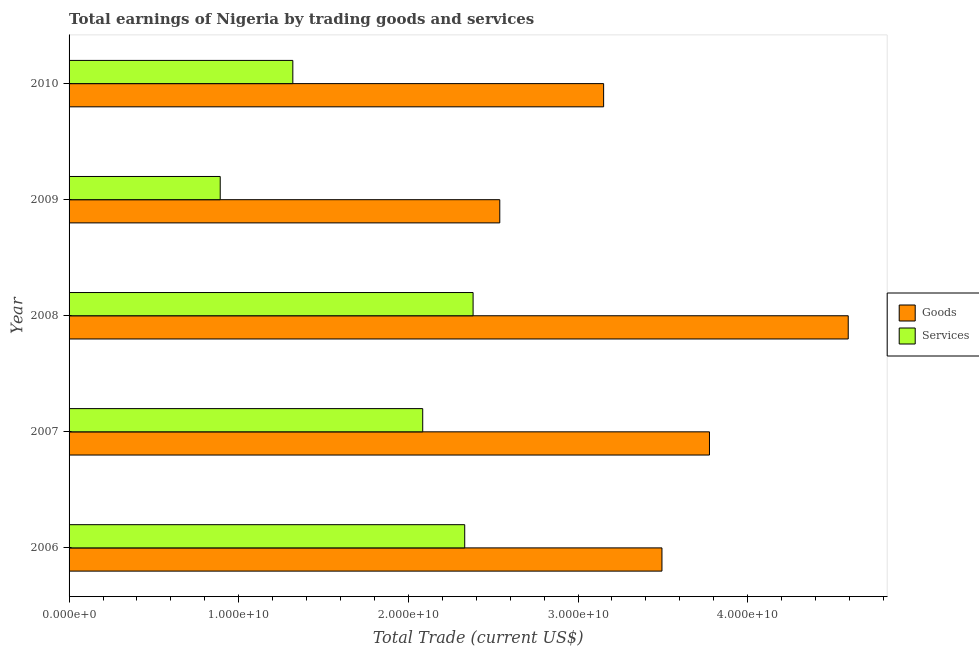How many different coloured bars are there?
Your response must be concise. 2. Are the number of bars per tick equal to the number of legend labels?
Your response must be concise. Yes. Are the number of bars on each tick of the Y-axis equal?
Your answer should be compact. Yes. How many bars are there on the 1st tick from the top?
Make the answer very short. 2. How many bars are there on the 3rd tick from the bottom?
Give a very brief answer. 2. What is the label of the 3rd group of bars from the top?
Keep it short and to the point. 2008. What is the amount earned by trading goods in 2010?
Your answer should be compact. 3.15e+1. Across all years, what is the maximum amount earned by trading services?
Ensure brevity in your answer.  2.38e+1. Across all years, what is the minimum amount earned by trading services?
Your answer should be compact. 8.91e+09. What is the total amount earned by trading services in the graph?
Your answer should be very brief. 9.01e+1. What is the difference between the amount earned by trading services in 2007 and that in 2009?
Provide a short and direct response. 1.19e+1. What is the difference between the amount earned by trading goods in 2009 and the amount earned by trading services in 2006?
Your response must be concise. 2.07e+09. What is the average amount earned by trading services per year?
Ensure brevity in your answer.  1.80e+1. In the year 2008, what is the difference between the amount earned by trading services and amount earned by trading goods?
Your response must be concise. -2.21e+1. What is the ratio of the amount earned by trading goods in 2007 to that in 2010?
Offer a very short reply. 1.2. Is the difference between the amount earned by trading goods in 2008 and 2010 greater than the difference between the amount earned by trading services in 2008 and 2010?
Ensure brevity in your answer.  Yes. What is the difference between the highest and the second highest amount earned by trading goods?
Provide a short and direct response. 8.18e+09. What is the difference between the highest and the lowest amount earned by trading goods?
Your response must be concise. 2.05e+1. In how many years, is the amount earned by trading goods greater than the average amount earned by trading goods taken over all years?
Your answer should be very brief. 2. What does the 2nd bar from the top in 2010 represents?
Your response must be concise. Goods. What does the 2nd bar from the bottom in 2007 represents?
Your answer should be compact. Services. How many bars are there?
Your answer should be compact. 10. How many years are there in the graph?
Provide a short and direct response. 5. Does the graph contain any zero values?
Give a very brief answer. No. Where does the legend appear in the graph?
Offer a terse response. Center right. How many legend labels are there?
Offer a terse response. 2. How are the legend labels stacked?
Offer a terse response. Vertical. What is the title of the graph?
Ensure brevity in your answer.  Total earnings of Nigeria by trading goods and services. Does "Old" appear as one of the legend labels in the graph?
Provide a short and direct response. No. What is the label or title of the X-axis?
Your answer should be compact. Total Trade (current US$). What is the Total Trade (current US$) of Goods in 2006?
Offer a very short reply. 3.49e+1. What is the Total Trade (current US$) in Services in 2006?
Offer a very short reply. 2.33e+1. What is the Total Trade (current US$) of Goods in 2007?
Ensure brevity in your answer.  3.77e+1. What is the Total Trade (current US$) of Services in 2007?
Make the answer very short. 2.08e+1. What is the Total Trade (current US$) of Goods in 2008?
Provide a short and direct response. 4.59e+1. What is the Total Trade (current US$) of Services in 2008?
Keep it short and to the point. 2.38e+1. What is the Total Trade (current US$) of Goods in 2009?
Keep it short and to the point. 2.54e+1. What is the Total Trade (current US$) in Services in 2009?
Your answer should be very brief. 8.91e+09. What is the Total Trade (current US$) in Goods in 2010?
Ensure brevity in your answer.  3.15e+1. What is the Total Trade (current US$) in Services in 2010?
Keep it short and to the point. 1.32e+1. Across all years, what is the maximum Total Trade (current US$) of Goods?
Ensure brevity in your answer.  4.59e+1. Across all years, what is the maximum Total Trade (current US$) in Services?
Provide a succinct answer. 2.38e+1. Across all years, what is the minimum Total Trade (current US$) of Goods?
Offer a very short reply. 2.54e+1. Across all years, what is the minimum Total Trade (current US$) of Services?
Give a very brief answer. 8.91e+09. What is the total Total Trade (current US$) of Goods in the graph?
Your answer should be very brief. 1.76e+11. What is the total Total Trade (current US$) in Services in the graph?
Keep it short and to the point. 9.01e+1. What is the difference between the Total Trade (current US$) of Goods in 2006 and that in 2007?
Make the answer very short. -2.80e+09. What is the difference between the Total Trade (current US$) of Services in 2006 and that in 2007?
Offer a very short reply. 2.48e+09. What is the difference between the Total Trade (current US$) of Goods in 2006 and that in 2008?
Offer a terse response. -1.10e+1. What is the difference between the Total Trade (current US$) in Services in 2006 and that in 2008?
Your answer should be compact. -4.93e+08. What is the difference between the Total Trade (current US$) in Goods in 2006 and that in 2009?
Keep it short and to the point. 9.56e+09. What is the difference between the Total Trade (current US$) in Services in 2006 and that in 2009?
Offer a terse response. 1.44e+1. What is the difference between the Total Trade (current US$) of Goods in 2006 and that in 2010?
Ensure brevity in your answer.  3.44e+09. What is the difference between the Total Trade (current US$) of Services in 2006 and that in 2010?
Provide a short and direct response. 1.01e+1. What is the difference between the Total Trade (current US$) in Goods in 2007 and that in 2008?
Your answer should be very brief. -8.18e+09. What is the difference between the Total Trade (current US$) of Services in 2007 and that in 2008?
Ensure brevity in your answer.  -2.97e+09. What is the difference between the Total Trade (current US$) in Goods in 2007 and that in 2009?
Provide a succinct answer. 1.24e+1. What is the difference between the Total Trade (current US$) in Services in 2007 and that in 2009?
Ensure brevity in your answer.  1.19e+1. What is the difference between the Total Trade (current US$) in Goods in 2007 and that in 2010?
Offer a terse response. 6.24e+09. What is the difference between the Total Trade (current US$) of Services in 2007 and that in 2010?
Provide a short and direct response. 7.66e+09. What is the difference between the Total Trade (current US$) of Goods in 2008 and that in 2009?
Keep it short and to the point. 2.05e+1. What is the difference between the Total Trade (current US$) in Services in 2008 and that in 2009?
Make the answer very short. 1.49e+1. What is the difference between the Total Trade (current US$) of Goods in 2008 and that in 2010?
Provide a succinct answer. 1.44e+1. What is the difference between the Total Trade (current US$) in Services in 2008 and that in 2010?
Provide a succinct answer. 1.06e+1. What is the difference between the Total Trade (current US$) of Goods in 2009 and that in 2010?
Keep it short and to the point. -6.12e+09. What is the difference between the Total Trade (current US$) in Services in 2009 and that in 2010?
Provide a short and direct response. -4.28e+09. What is the difference between the Total Trade (current US$) of Goods in 2006 and the Total Trade (current US$) of Services in 2007?
Offer a very short reply. 1.41e+1. What is the difference between the Total Trade (current US$) of Goods in 2006 and the Total Trade (current US$) of Services in 2008?
Keep it short and to the point. 1.11e+1. What is the difference between the Total Trade (current US$) of Goods in 2006 and the Total Trade (current US$) of Services in 2009?
Ensure brevity in your answer.  2.60e+1. What is the difference between the Total Trade (current US$) of Goods in 2006 and the Total Trade (current US$) of Services in 2010?
Provide a succinct answer. 2.18e+1. What is the difference between the Total Trade (current US$) of Goods in 2007 and the Total Trade (current US$) of Services in 2008?
Your response must be concise. 1.39e+1. What is the difference between the Total Trade (current US$) of Goods in 2007 and the Total Trade (current US$) of Services in 2009?
Your answer should be very brief. 2.88e+1. What is the difference between the Total Trade (current US$) of Goods in 2007 and the Total Trade (current US$) of Services in 2010?
Make the answer very short. 2.46e+1. What is the difference between the Total Trade (current US$) in Goods in 2008 and the Total Trade (current US$) in Services in 2009?
Keep it short and to the point. 3.70e+1. What is the difference between the Total Trade (current US$) of Goods in 2008 and the Total Trade (current US$) of Services in 2010?
Keep it short and to the point. 3.27e+1. What is the difference between the Total Trade (current US$) of Goods in 2009 and the Total Trade (current US$) of Services in 2010?
Offer a terse response. 1.22e+1. What is the average Total Trade (current US$) of Goods per year?
Make the answer very short. 3.51e+1. What is the average Total Trade (current US$) of Services per year?
Keep it short and to the point. 1.80e+1. In the year 2006, what is the difference between the Total Trade (current US$) in Goods and Total Trade (current US$) in Services?
Give a very brief answer. 1.16e+1. In the year 2007, what is the difference between the Total Trade (current US$) of Goods and Total Trade (current US$) of Services?
Provide a short and direct response. 1.69e+1. In the year 2008, what is the difference between the Total Trade (current US$) in Goods and Total Trade (current US$) in Services?
Give a very brief answer. 2.21e+1. In the year 2009, what is the difference between the Total Trade (current US$) in Goods and Total Trade (current US$) in Services?
Make the answer very short. 1.65e+1. In the year 2010, what is the difference between the Total Trade (current US$) in Goods and Total Trade (current US$) in Services?
Your response must be concise. 1.83e+1. What is the ratio of the Total Trade (current US$) in Goods in 2006 to that in 2007?
Keep it short and to the point. 0.93. What is the ratio of the Total Trade (current US$) of Services in 2006 to that in 2007?
Your response must be concise. 1.12. What is the ratio of the Total Trade (current US$) of Goods in 2006 to that in 2008?
Your response must be concise. 0.76. What is the ratio of the Total Trade (current US$) in Services in 2006 to that in 2008?
Provide a short and direct response. 0.98. What is the ratio of the Total Trade (current US$) of Goods in 2006 to that in 2009?
Make the answer very short. 1.38. What is the ratio of the Total Trade (current US$) in Services in 2006 to that in 2009?
Provide a short and direct response. 2.62. What is the ratio of the Total Trade (current US$) of Goods in 2006 to that in 2010?
Give a very brief answer. 1.11. What is the ratio of the Total Trade (current US$) in Services in 2006 to that in 2010?
Ensure brevity in your answer.  1.77. What is the ratio of the Total Trade (current US$) in Goods in 2007 to that in 2008?
Offer a terse response. 0.82. What is the ratio of the Total Trade (current US$) in Services in 2007 to that in 2008?
Provide a succinct answer. 0.88. What is the ratio of the Total Trade (current US$) in Goods in 2007 to that in 2009?
Ensure brevity in your answer.  1.49. What is the ratio of the Total Trade (current US$) of Services in 2007 to that in 2009?
Offer a terse response. 2.34. What is the ratio of the Total Trade (current US$) of Goods in 2007 to that in 2010?
Give a very brief answer. 1.2. What is the ratio of the Total Trade (current US$) of Services in 2007 to that in 2010?
Give a very brief answer. 1.58. What is the ratio of the Total Trade (current US$) in Goods in 2008 to that in 2009?
Ensure brevity in your answer.  1.81. What is the ratio of the Total Trade (current US$) of Services in 2008 to that in 2009?
Offer a terse response. 2.67. What is the ratio of the Total Trade (current US$) of Goods in 2008 to that in 2010?
Provide a short and direct response. 1.46. What is the ratio of the Total Trade (current US$) in Services in 2008 to that in 2010?
Offer a very short reply. 1.81. What is the ratio of the Total Trade (current US$) of Goods in 2009 to that in 2010?
Your response must be concise. 0.81. What is the ratio of the Total Trade (current US$) in Services in 2009 to that in 2010?
Give a very brief answer. 0.68. What is the difference between the highest and the second highest Total Trade (current US$) of Goods?
Keep it short and to the point. 8.18e+09. What is the difference between the highest and the second highest Total Trade (current US$) of Services?
Your answer should be very brief. 4.93e+08. What is the difference between the highest and the lowest Total Trade (current US$) in Goods?
Your answer should be compact. 2.05e+1. What is the difference between the highest and the lowest Total Trade (current US$) in Services?
Your answer should be compact. 1.49e+1. 